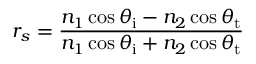Convert formula to latex. <formula><loc_0><loc_0><loc_500><loc_500>r _ { s } = { \frac { n _ { 1 } \cos \theta _ { i } - n _ { 2 } \cos \theta _ { t } } { n _ { 1 } \cos \theta _ { i } + n _ { 2 } \cos \theta _ { t } } }</formula> 